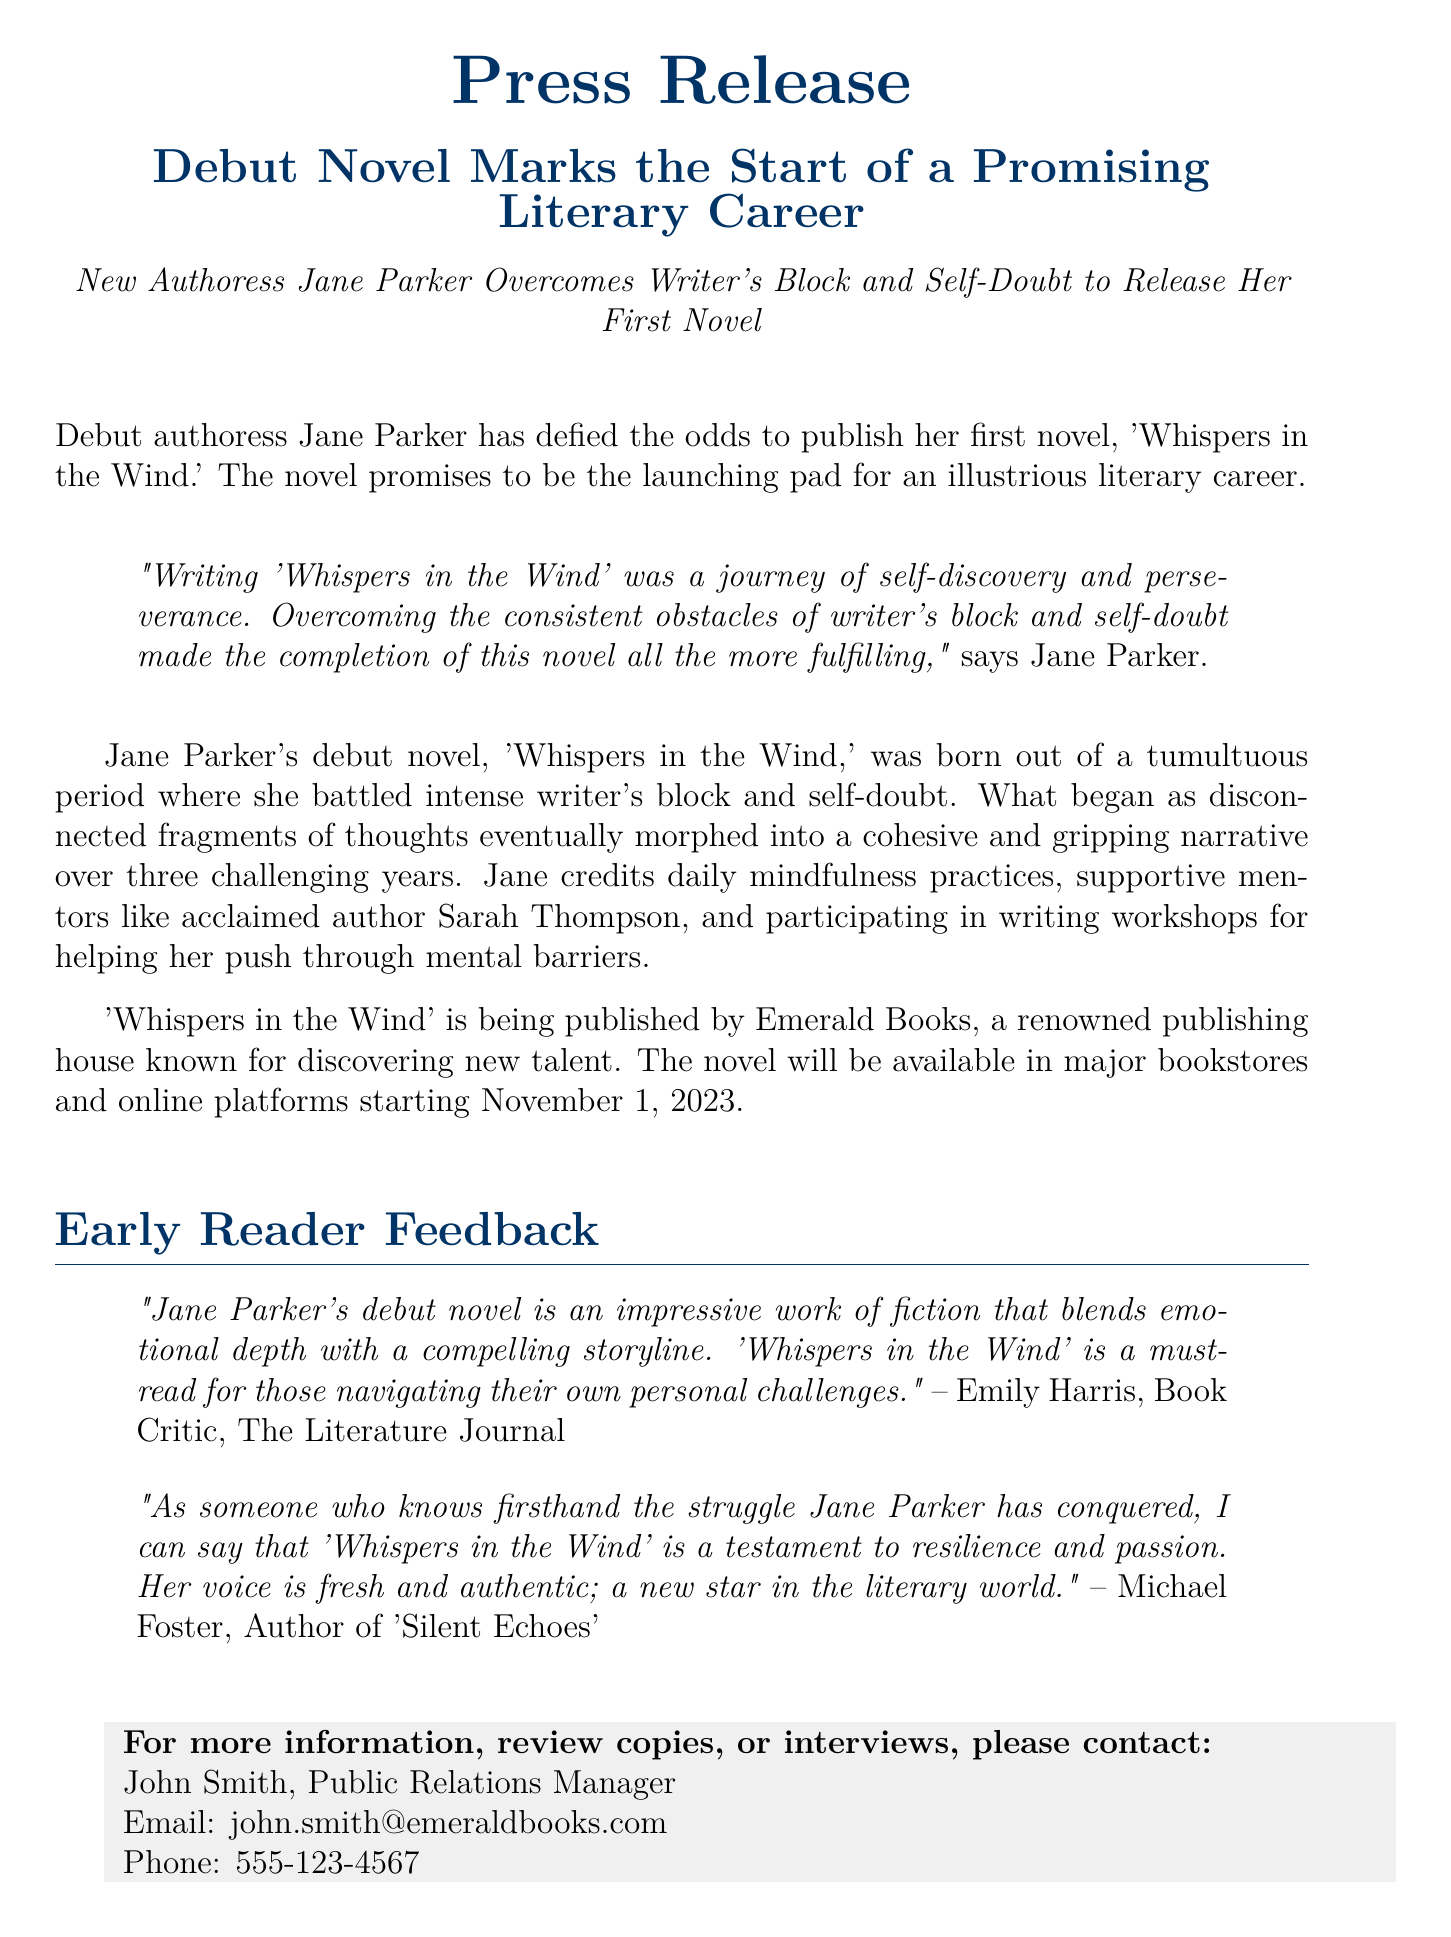What is the title of Jane Parker's debut novel? The title of the debut novel is mentioned in the press release, which is 'Whispers in the Wind.'
Answer: 'Whispers in the Wind' Who is the publisher of the novel? The press release states that the novel is being published by Emerald Books.
Answer: Emerald Books When will the novel be available in bookstores? The press release specifies that the novel will be available starting November 1, 2023.
Answer: November 1, 2023 What did Jane Parker describe 'Whispers in the Wind' as? In her quote, Jane Parker described the writing of the novel as a journey of self-discovery and perseverance.
Answer: a journey of self-discovery and perseverance Who provided early reader feedback stating that the novel is a "must-read"? The feedback stating 'Whispers in the Wind' is a must-read was provided by Emily Harris.
Answer: Emily Harris Which acclaimed author supported Jane Parker? The press release mentions that Jane credited acclaimed author Sarah Thompson as a supportive mentor.
Answer: Sarah Thompson What are the two main challenges Jane Parker faced while writing her novel? The document explicitly mentions writer's block and self-doubt as the main challenges she faced.
Answer: writer's block and self-doubt How long did it take Jane Parker to complete her novel? The document states that it took three challenging years for Jane Parker to complete her novel.
Answer: three years What theme is highlighted in the early reader feedback from Michael Foster? The feedback highlights resilience and passion as significant themes in Jane Parker's work.
Answer: resilience and passion 